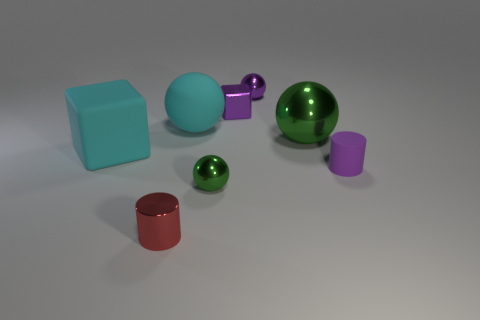There is a block that is the same color as the matte sphere; what material is it?
Offer a very short reply. Rubber. Is there anything else that has the same shape as the big green object?
Provide a succinct answer. Yes. There is a rubber thing that is left of the large matte sphere; is there a small shiny block that is on the left side of it?
Your answer should be compact. No. Is the number of purple rubber cylinders to the left of the small purple sphere less than the number of purple metallic balls that are in front of the red shiny thing?
Ensure brevity in your answer.  No. How big is the cylinder behind the small cylinder in front of the small green metallic sphere in front of the purple metallic cube?
Your answer should be compact. Small. Do the cyan rubber thing that is left of the shiny cylinder and the metallic cylinder have the same size?
Ensure brevity in your answer.  No. What number of other objects are there of the same material as the small cube?
Give a very brief answer. 4. Are there more blue spheres than small green metallic objects?
Your answer should be compact. No. What material is the cylinder in front of the tiny green metal object in front of the cylinder that is behind the small red metallic object made of?
Offer a terse response. Metal. Is the rubber ball the same color as the small cube?
Keep it short and to the point. No. 